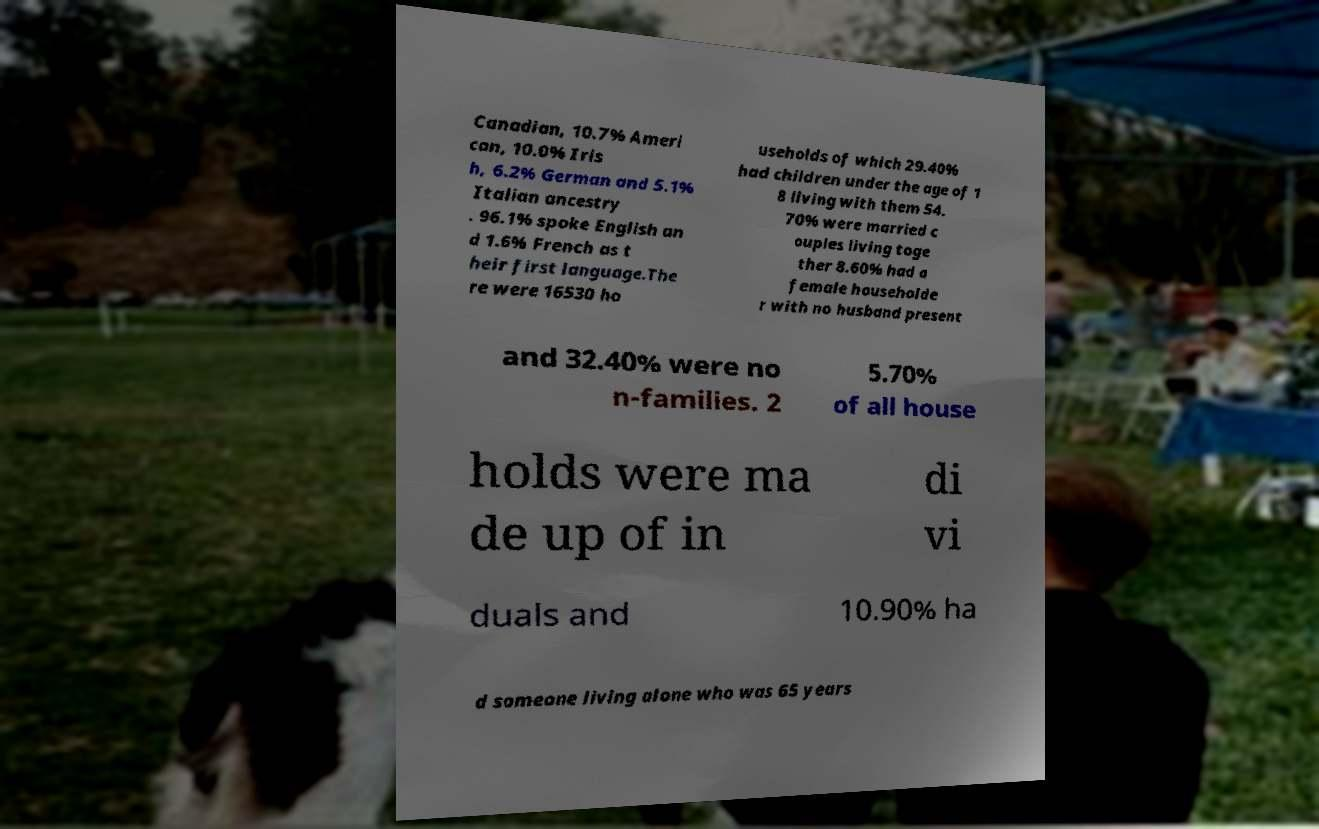I need the written content from this picture converted into text. Can you do that? Canadian, 10.7% Ameri can, 10.0% Iris h, 6.2% German and 5.1% Italian ancestry . 96.1% spoke English an d 1.6% French as t heir first language.The re were 16530 ho useholds of which 29.40% had children under the age of 1 8 living with them 54. 70% were married c ouples living toge ther 8.60% had a female householde r with no husband present and 32.40% were no n-families. 2 5.70% of all house holds were ma de up of in di vi duals and 10.90% ha d someone living alone who was 65 years 